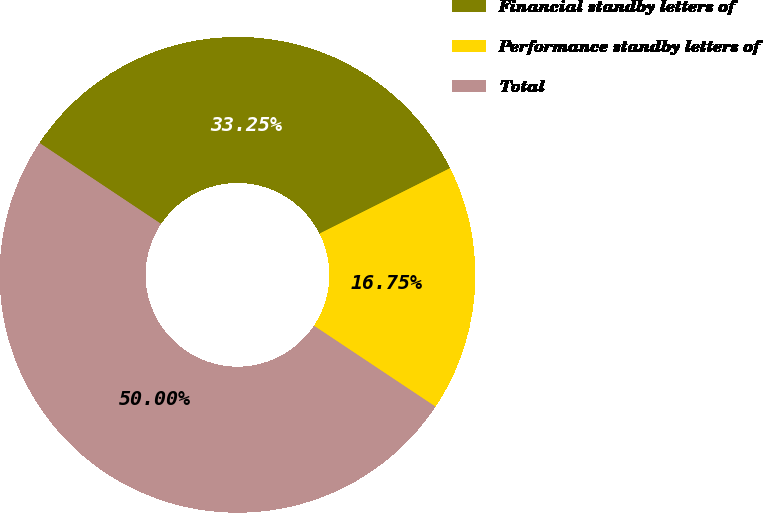Convert chart to OTSL. <chart><loc_0><loc_0><loc_500><loc_500><pie_chart><fcel>Financial standby letters of<fcel>Performance standby letters of<fcel>Total<nl><fcel>33.25%<fcel>16.75%<fcel>50.0%<nl></chart> 